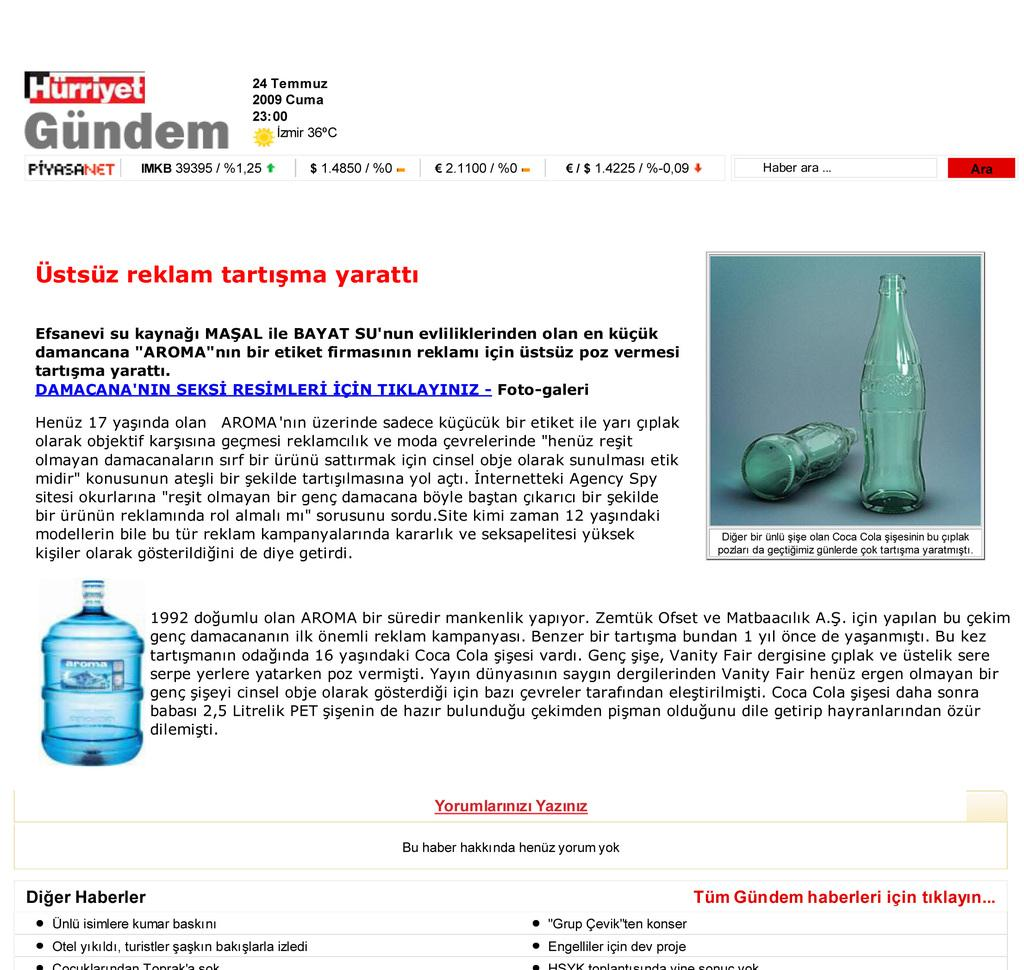<image>
Give a short and clear explanation of the subsequent image. An article featuring pictures of water bottles called Gundem. 